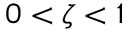<formula> <loc_0><loc_0><loc_500><loc_500>0 < \zeta < 1</formula> 